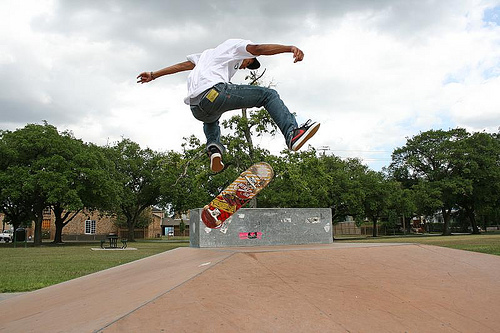<image>
Can you confirm if the skateboard is on the man? No. The skateboard is not positioned on the man. They may be near each other, but the skateboard is not supported by or resting on top of the man. Is there a person on the tree? No. The person is not positioned on the tree. They may be near each other, but the person is not supported by or resting on top of the tree. 